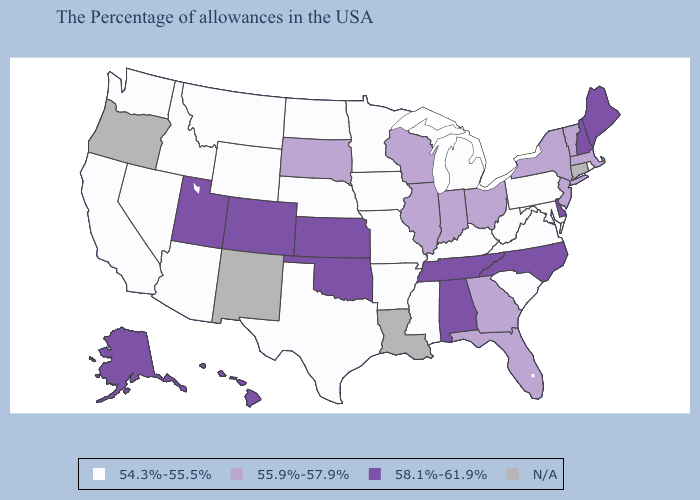What is the value of California?
Quick response, please. 54.3%-55.5%. Among the states that border New York , does Pennsylvania have the highest value?
Concise answer only. No. Name the states that have a value in the range N/A?
Write a very short answer. Connecticut, Louisiana, New Mexico, Oregon. Which states hav the highest value in the Northeast?
Give a very brief answer. Maine, New Hampshire. Which states have the highest value in the USA?
Concise answer only. Maine, New Hampshire, Delaware, North Carolina, Alabama, Tennessee, Kansas, Oklahoma, Colorado, Utah, Alaska, Hawaii. Is the legend a continuous bar?
Write a very short answer. No. Which states have the highest value in the USA?
Give a very brief answer. Maine, New Hampshire, Delaware, North Carolina, Alabama, Tennessee, Kansas, Oklahoma, Colorado, Utah, Alaska, Hawaii. Name the states that have a value in the range 54.3%-55.5%?
Concise answer only. Rhode Island, Maryland, Pennsylvania, Virginia, South Carolina, West Virginia, Michigan, Kentucky, Mississippi, Missouri, Arkansas, Minnesota, Iowa, Nebraska, Texas, North Dakota, Wyoming, Montana, Arizona, Idaho, Nevada, California, Washington. What is the lowest value in the USA?
Give a very brief answer. 54.3%-55.5%. What is the value of Alaska?
Write a very short answer. 58.1%-61.9%. What is the value of California?
Write a very short answer. 54.3%-55.5%. Name the states that have a value in the range 58.1%-61.9%?
Keep it brief. Maine, New Hampshire, Delaware, North Carolina, Alabama, Tennessee, Kansas, Oklahoma, Colorado, Utah, Alaska, Hawaii. What is the value of Arizona?
Keep it brief. 54.3%-55.5%. Which states have the highest value in the USA?
Write a very short answer. Maine, New Hampshire, Delaware, North Carolina, Alabama, Tennessee, Kansas, Oklahoma, Colorado, Utah, Alaska, Hawaii. Does Kansas have the highest value in the USA?
Be succinct. Yes. 